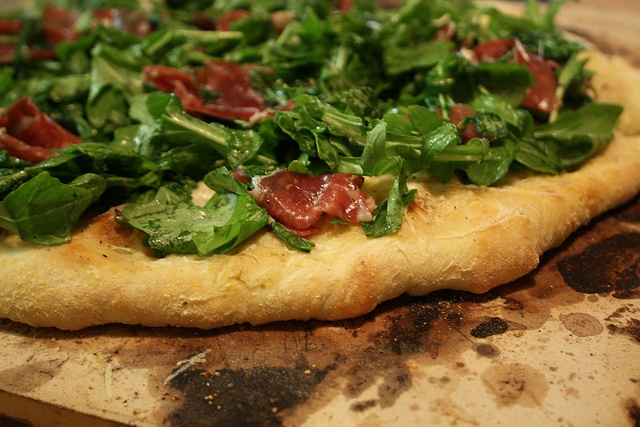Describe the objects in this image and their specific colors. I can see a pizza in gray, darkgreen, black, and tan tones in this image. 